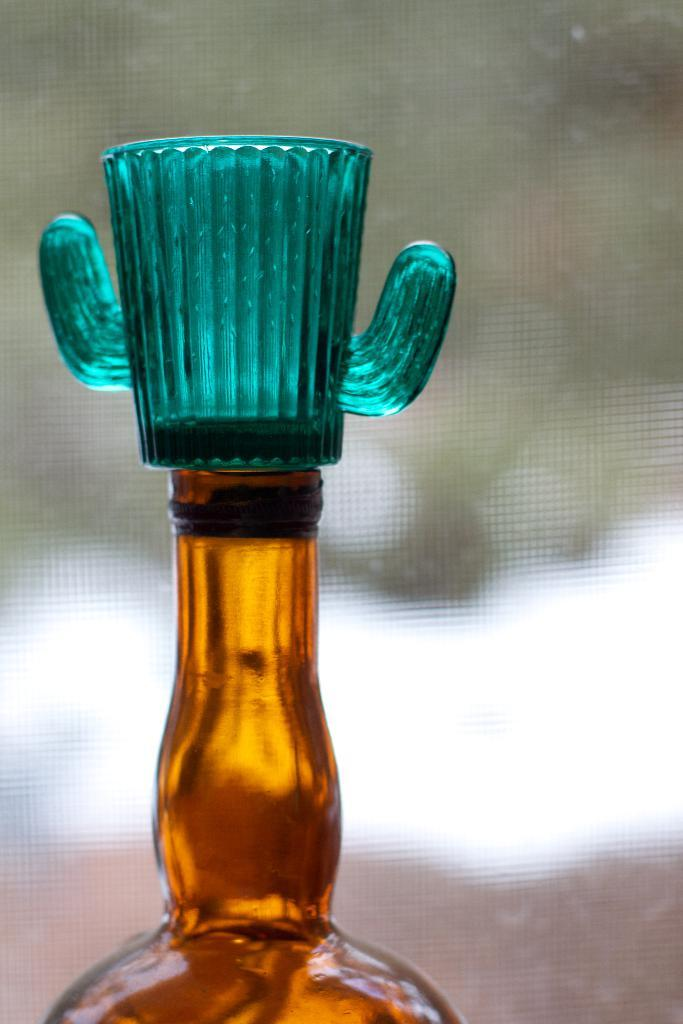What object can be seen in the image? There is a bottle in the image. Is there anything placed on the bottle? Yes, there is a cup placed on the bottle. What is the baby learning in the image? There is no baby or learning activity present in the image; it only features a bottle with a cup on it. 